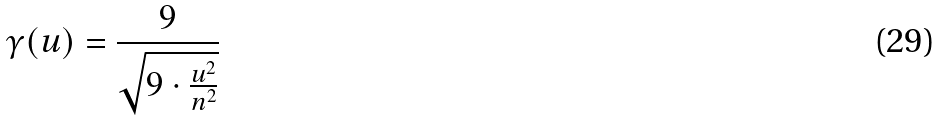Convert formula to latex. <formula><loc_0><loc_0><loc_500><loc_500>\gamma ( u ) = \frac { 9 } { \sqrt { 9 \cdot \frac { u ^ { 2 } } { n ^ { 2 } } } }</formula> 